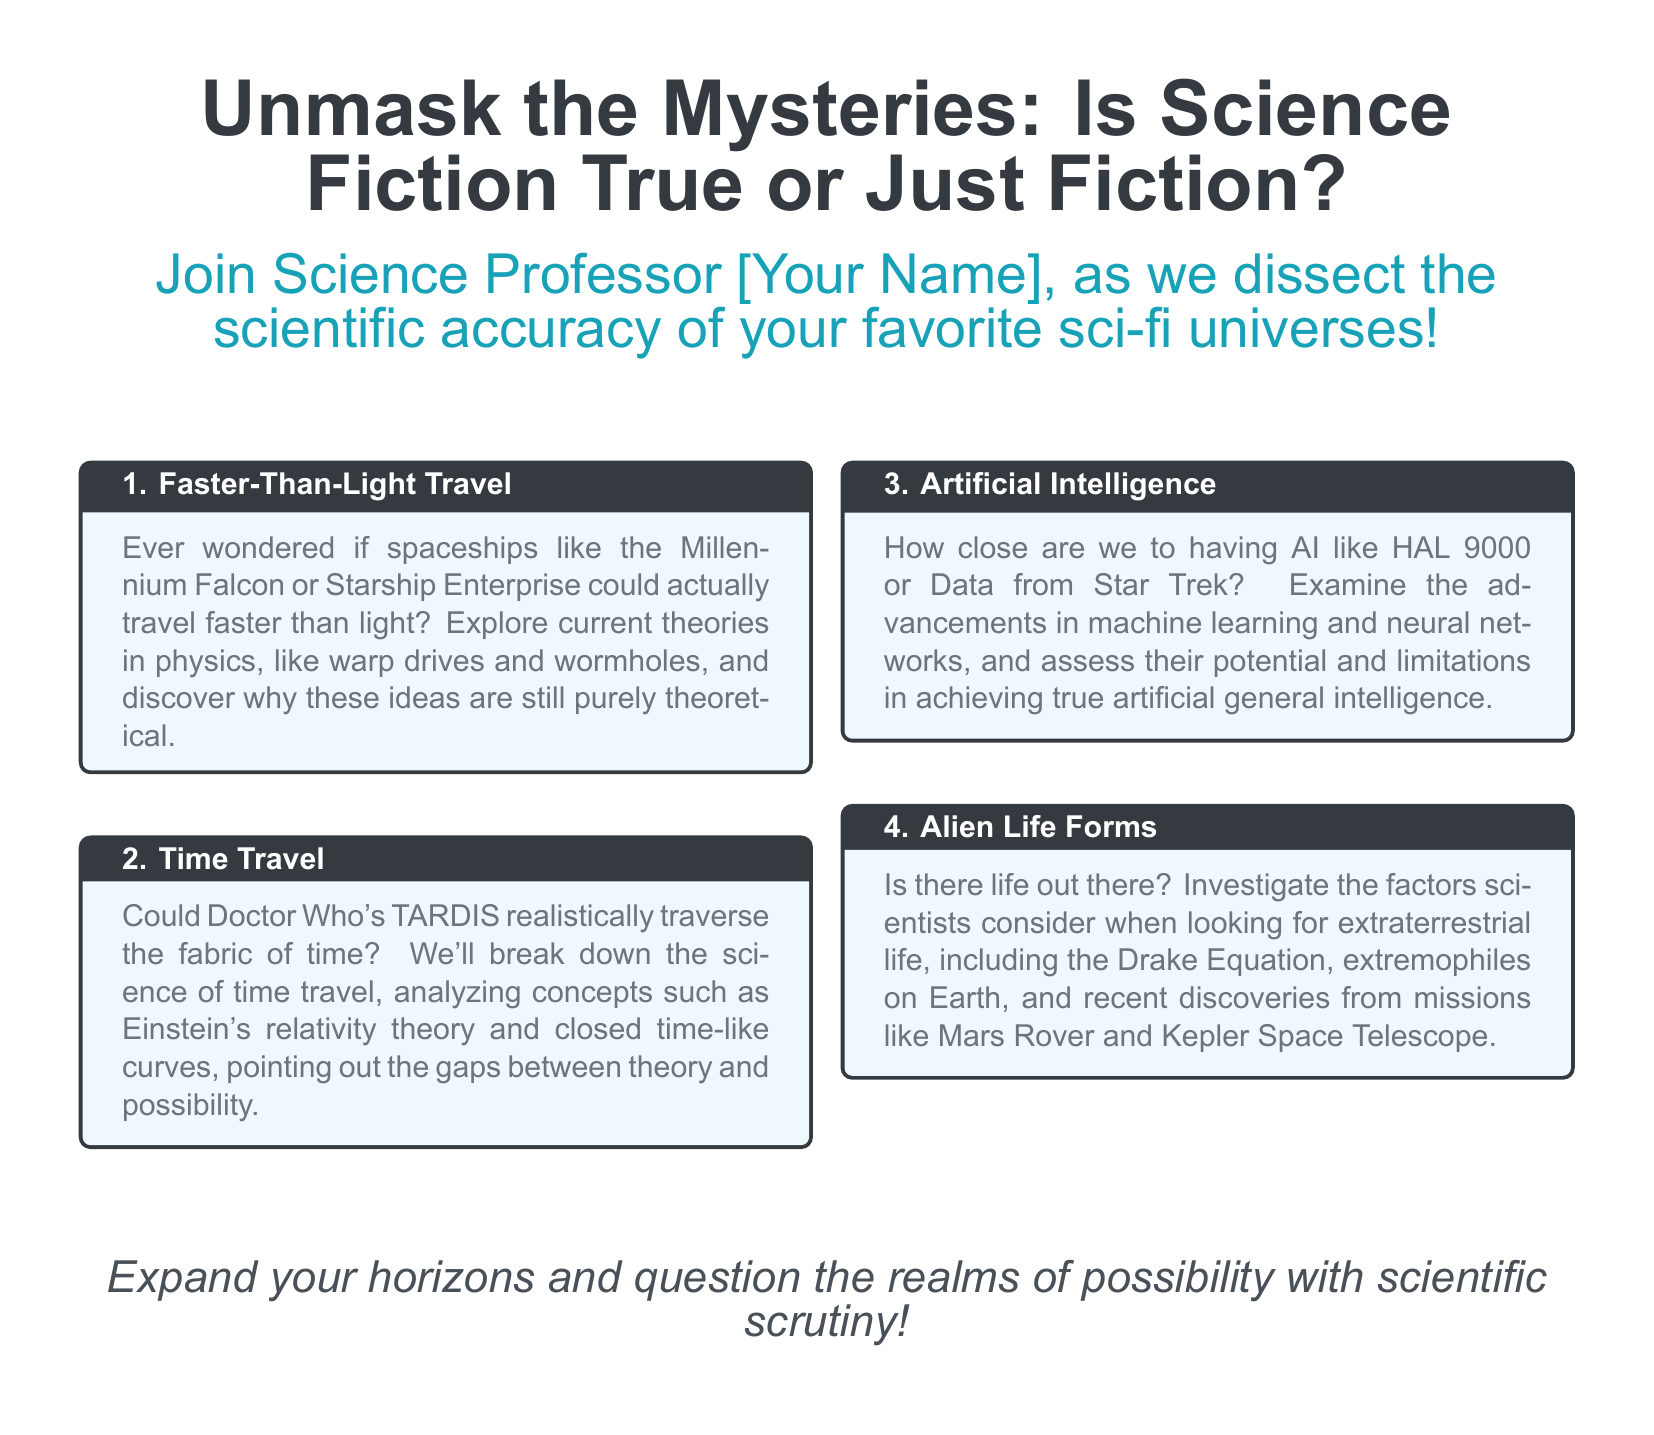What is the main topic of the advertisement? The document discusses the scientific analysis of popular science fiction tropes.
Answer: Debunking Sci-Fi Who is the target speaker in the advertisement? The advertisement features a science professor who dissects the accuracy of sci-fi universes.
Answer: Science Professor [Your Name] What is one of the sci-fi elements discussed related to time travel? The advertisement mentions concepts such as Einstein's relativity theory and closed time-like curves in the context of time travel.
Answer: Time Travel What fictional spaceship is mentioned as a faster-than-light travel example? The advertisement cites the Millennium Falcon as an example of faster-than-light travel.
Answer: Millennium Falcon What is one method mentioned for finding extraterrestrial life? The document discusses the Drake Equation as a factor in the search for extraterrestrial life.
Answer: Drake Equation What is suggested about the current state of artificial intelligence? The advertisement states there are advancements in machine learning and neural networks but discusses their limitations in achieving true artificial general intelligence.
Answer: Limitations What is the color of the header in the advertisement? The advertisement uses a specific RGB value for the header color, set to indicate its design choice.
Answer: RGB(52,58,64) What is the intended effect of questioning the realms of possibility? The advertisement aims to encourage readers to expand their horizons with scientific scrutiny.
Answer: Expand your horizons 